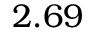Convert formula to latex. <formula><loc_0><loc_0><loc_500><loc_500>2 . 6 9</formula> 